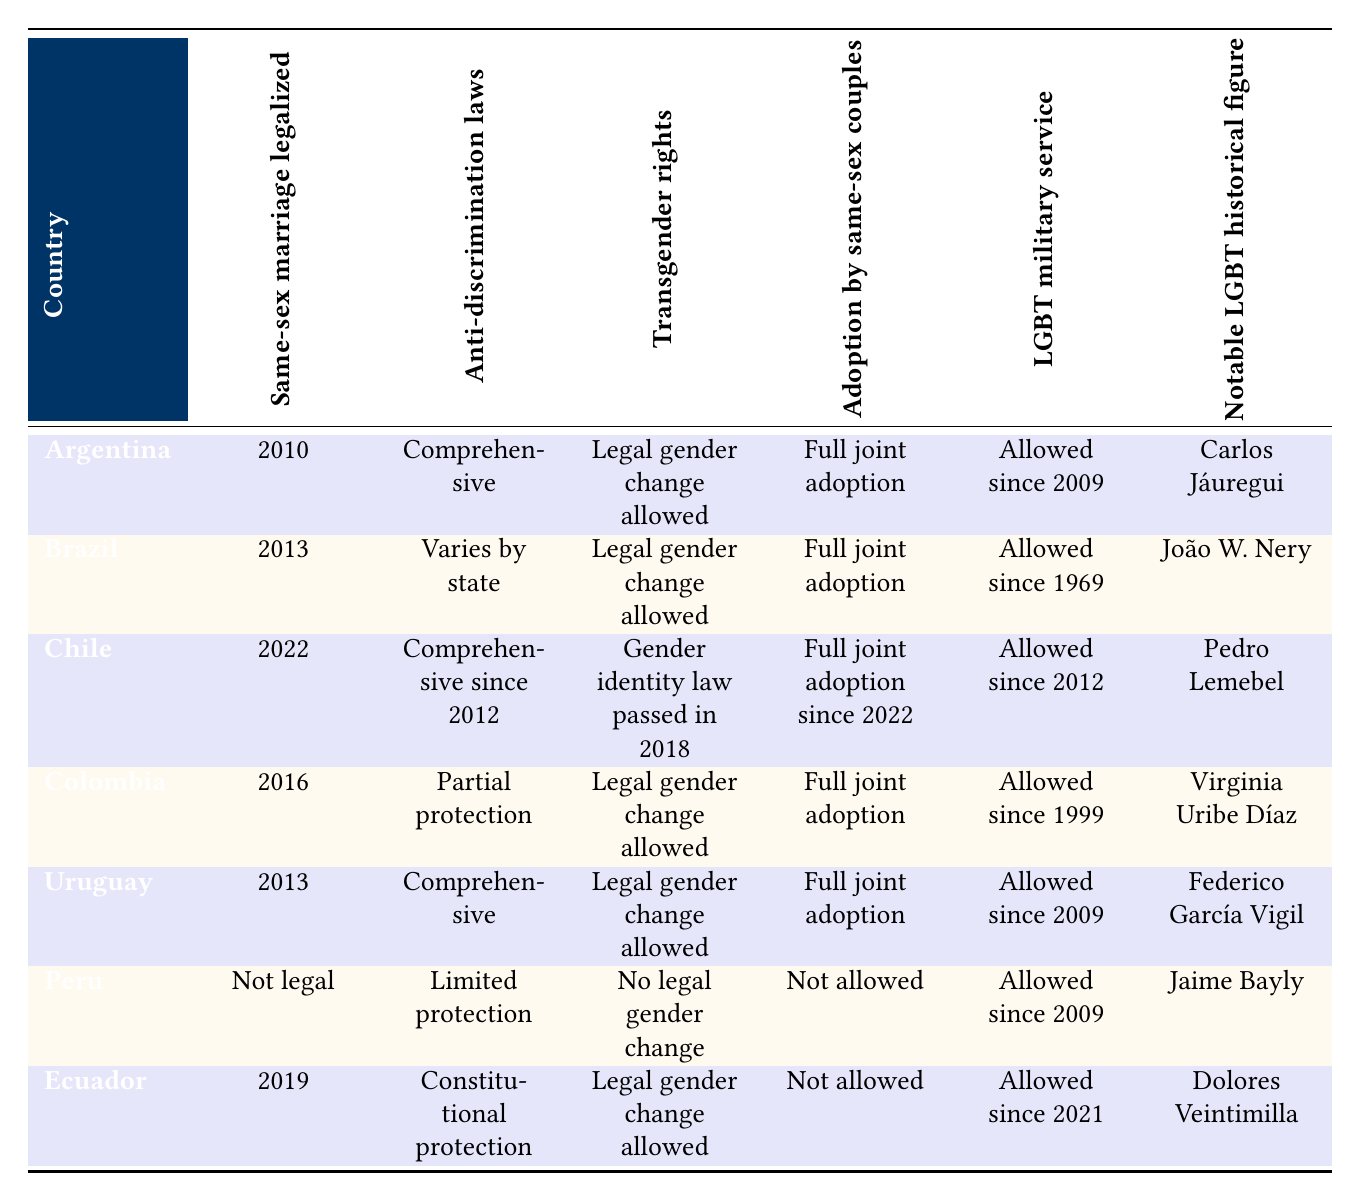What year was same-sex marriage legalized in Uruguay? According to the table, same-sex marriage was legalized in Uruguay in 2013. This data is found in the row corresponding to Uruguay under the "Same-sex marriage legalized" column.
Answer: 2013 Does Brazil have comprehensive anti-discrimination laws? The table indicates that Brazil's anti-discrimination laws "Varies by state." This means that the legal protections against discrimination based on sexual orientation are not uniform across the country, indicating a lack of comprehensive laws.
Answer: No Which countries allow full joint adoption by same-sex couples? To answer this, we look at the "Adoption by same-sex couples" column. The countries listed as allowing full joint adoption are Argentina, Brazil, Chile, Colombia, and Uruguay. This requires filtering through five rows to identify countries with "Full joint adoption."
Answer: Argentina, Brazil, Chile, Colombia, Uruguay How many countries have legal gender change allowed for transgender rights? By examining the "Transgender rights" column, we find that Argentina, Brazil, Chile, Colombia, and Ecuador allow legal gender change. Counting these rows gives us a total of five countries with this legal provision.
Answer: 5 Is Ecuador's LGBT military service policy more recent than Chile's? The table shows that Ecuador allows LGBT military service since 2021, while Chile allowed it since 2012. By comparing these dates, we can see that 2021 is more recent than 2012, affirming that Ecuador's policy is newer.
Answer: Yes What is the notable LGBT historical figure from Colombia? The row for Colombia indicates that the notable LGBT historical figure is Virginia Uribe Díaz, referenced in the corresponding column. This is a straightforward retrieval from the table's data.
Answer: Virginia Uribe Díaz Which country has the most recent legalization of same-sex marriage? The most recent date under the "Same-sex marriage legalized" column is 2022, associated with Chile. This is determined by comparing the legalization years for all listed countries.
Answer: Chile How many countries do not allow same-sex marriage? From the table, only Peru is listed with "Not legal" under the "Same-sex marriage legalized" column. Thus, we only count one country that does not allow it.
Answer: 1 In which two countries were notable LGBT historical figures born between 1969 and 2019? Looking at the table, João W. Nery from Brazil (born in 2013) and Dolores Veintimilla from Ecuador (born in 2019) fall within this range, based on their noted years. Both figures meet the criteria, requiring cross-referencing the "Notable LGBT historical figure" column with their respective countries.
Answer: Brazil, Ecuador 